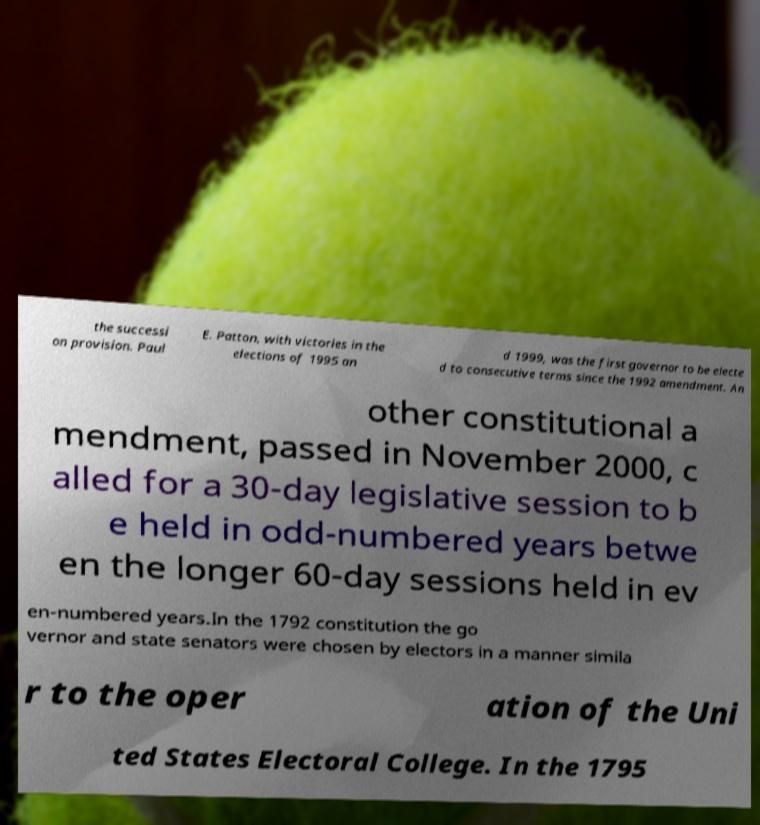Please identify and transcribe the text found in this image. the successi on provision. Paul E. Patton, with victories in the elections of 1995 an d 1999, was the first governor to be electe d to consecutive terms since the 1992 amendment. An other constitutional a mendment, passed in November 2000, c alled for a 30-day legislative session to b e held in odd-numbered years betwe en the longer 60-day sessions held in ev en-numbered years.In the 1792 constitution the go vernor and state senators were chosen by electors in a manner simila r to the oper ation of the Uni ted States Electoral College. In the 1795 